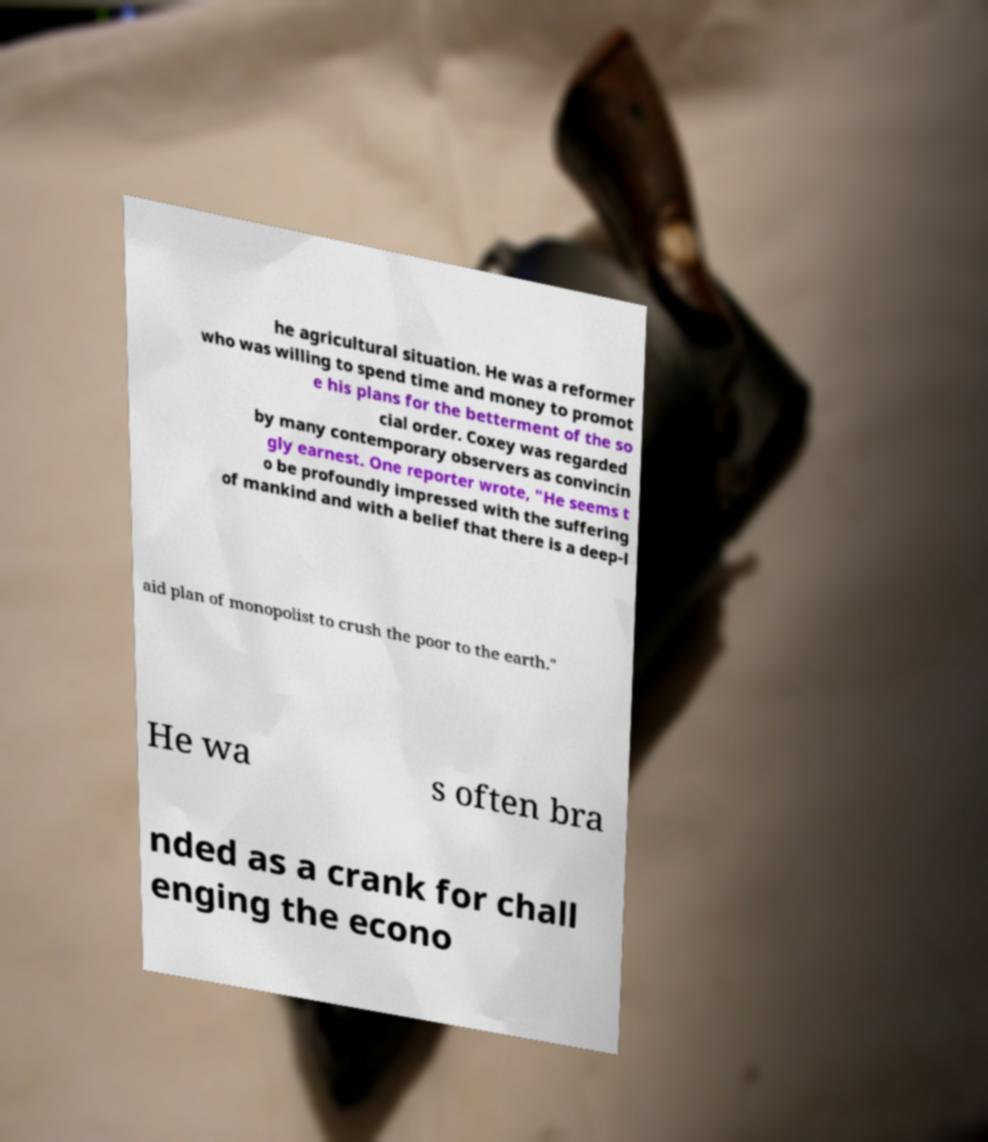Could you extract and type out the text from this image? he agricultural situation. He was a reformer who was willing to spend time and money to promot e his plans for the betterment of the so cial order. Coxey was regarded by many contemporary observers as convincin gly earnest. One reporter wrote, "He seems t o be profoundly impressed with the suffering of mankind and with a belief that there is a deep-l aid plan of monopolist to crush the poor to the earth." He wa s often bra nded as a crank for chall enging the econo 